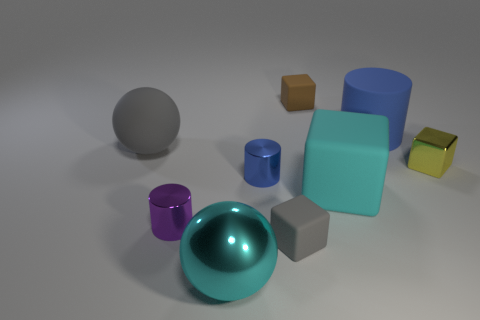There is a matte cube that is the same color as the big metal object; what is its size?
Ensure brevity in your answer.  Large. What color is the shiny cylinder that is on the right side of the big cyan metallic thing?
Offer a very short reply. Blue. Is the shape of the tiny blue shiny thing the same as the blue thing that is behind the yellow thing?
Provide a succinct answer. Yes. Is there a matte block that has the same color as the large matte cylinder?
Ensure brevity in your answer.  No. What is the size of the gray cube that is the same material as the cyan block?
Keep it short and to the point. Small. Is the color of the big shiny object the same as the large matte cube?
Provide a short and direct response. Yes. There is a object behind the large blue matte thing; does it have the same shape as the tiny purple shiny object?
Offer a very short reply. No. What number of cyan matte blocks are the same size as the brown object?
Make the answer very short. 0. There is a metal object that is the same color as the big cube; what shape is it?
Your answer should be very brief. Sphere. Are there any big cylinders that are to the right of the large ball that is in front of the tiny yellow metal cube?
Offer a terse response. Yes. 